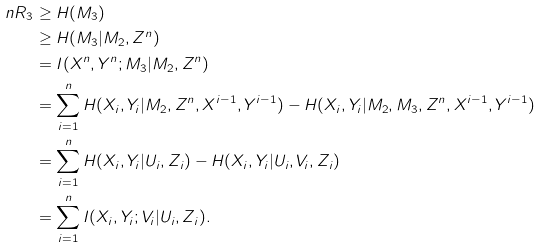Convert formula to latex. <formula><loc_0><loc_0><loc_500><loc_500>n R _ { 3 } & \geq H ( M _ { 3 } ) \\ & \geq H ( M _ { 3 } | M _ { 2 } , Z ^ { n } ) \\ & = I ( X ^ { n } , Y ^ { n } ; M _ { 3 } | M _ { 2 } , Z ^ { n } ) \\ & = \sum _ { i = 1 } ^ { n } H ( X _ { i } , Y _ { i } | M _ { 2 } , Z ^ { n } , X ^ { i - 1 } , Y ^ { i - 1 } ) - H ( X _ { i } , Y _ { i } | M _ { 2 } , M _ { 3 } , Z ^ { n } , X ^ { i - 1 } , Y ^ { i - 1 } ) \\ & = \sum _ { i = 1 } ^ { n } H ( X _ { i } , Y _ { i } | U _ { i } , Z _ { i } ) - H ( X _ { i } , Y _ { i } | U _ { i } , V _ { i } , Z _ { i } ) \\ & = \sum _ { i = 1 } ^ { n } I ( X _ { i } , Y _ { i } ; V _ { i } | U _ { i } , Z _ { i } ) .</formula> 